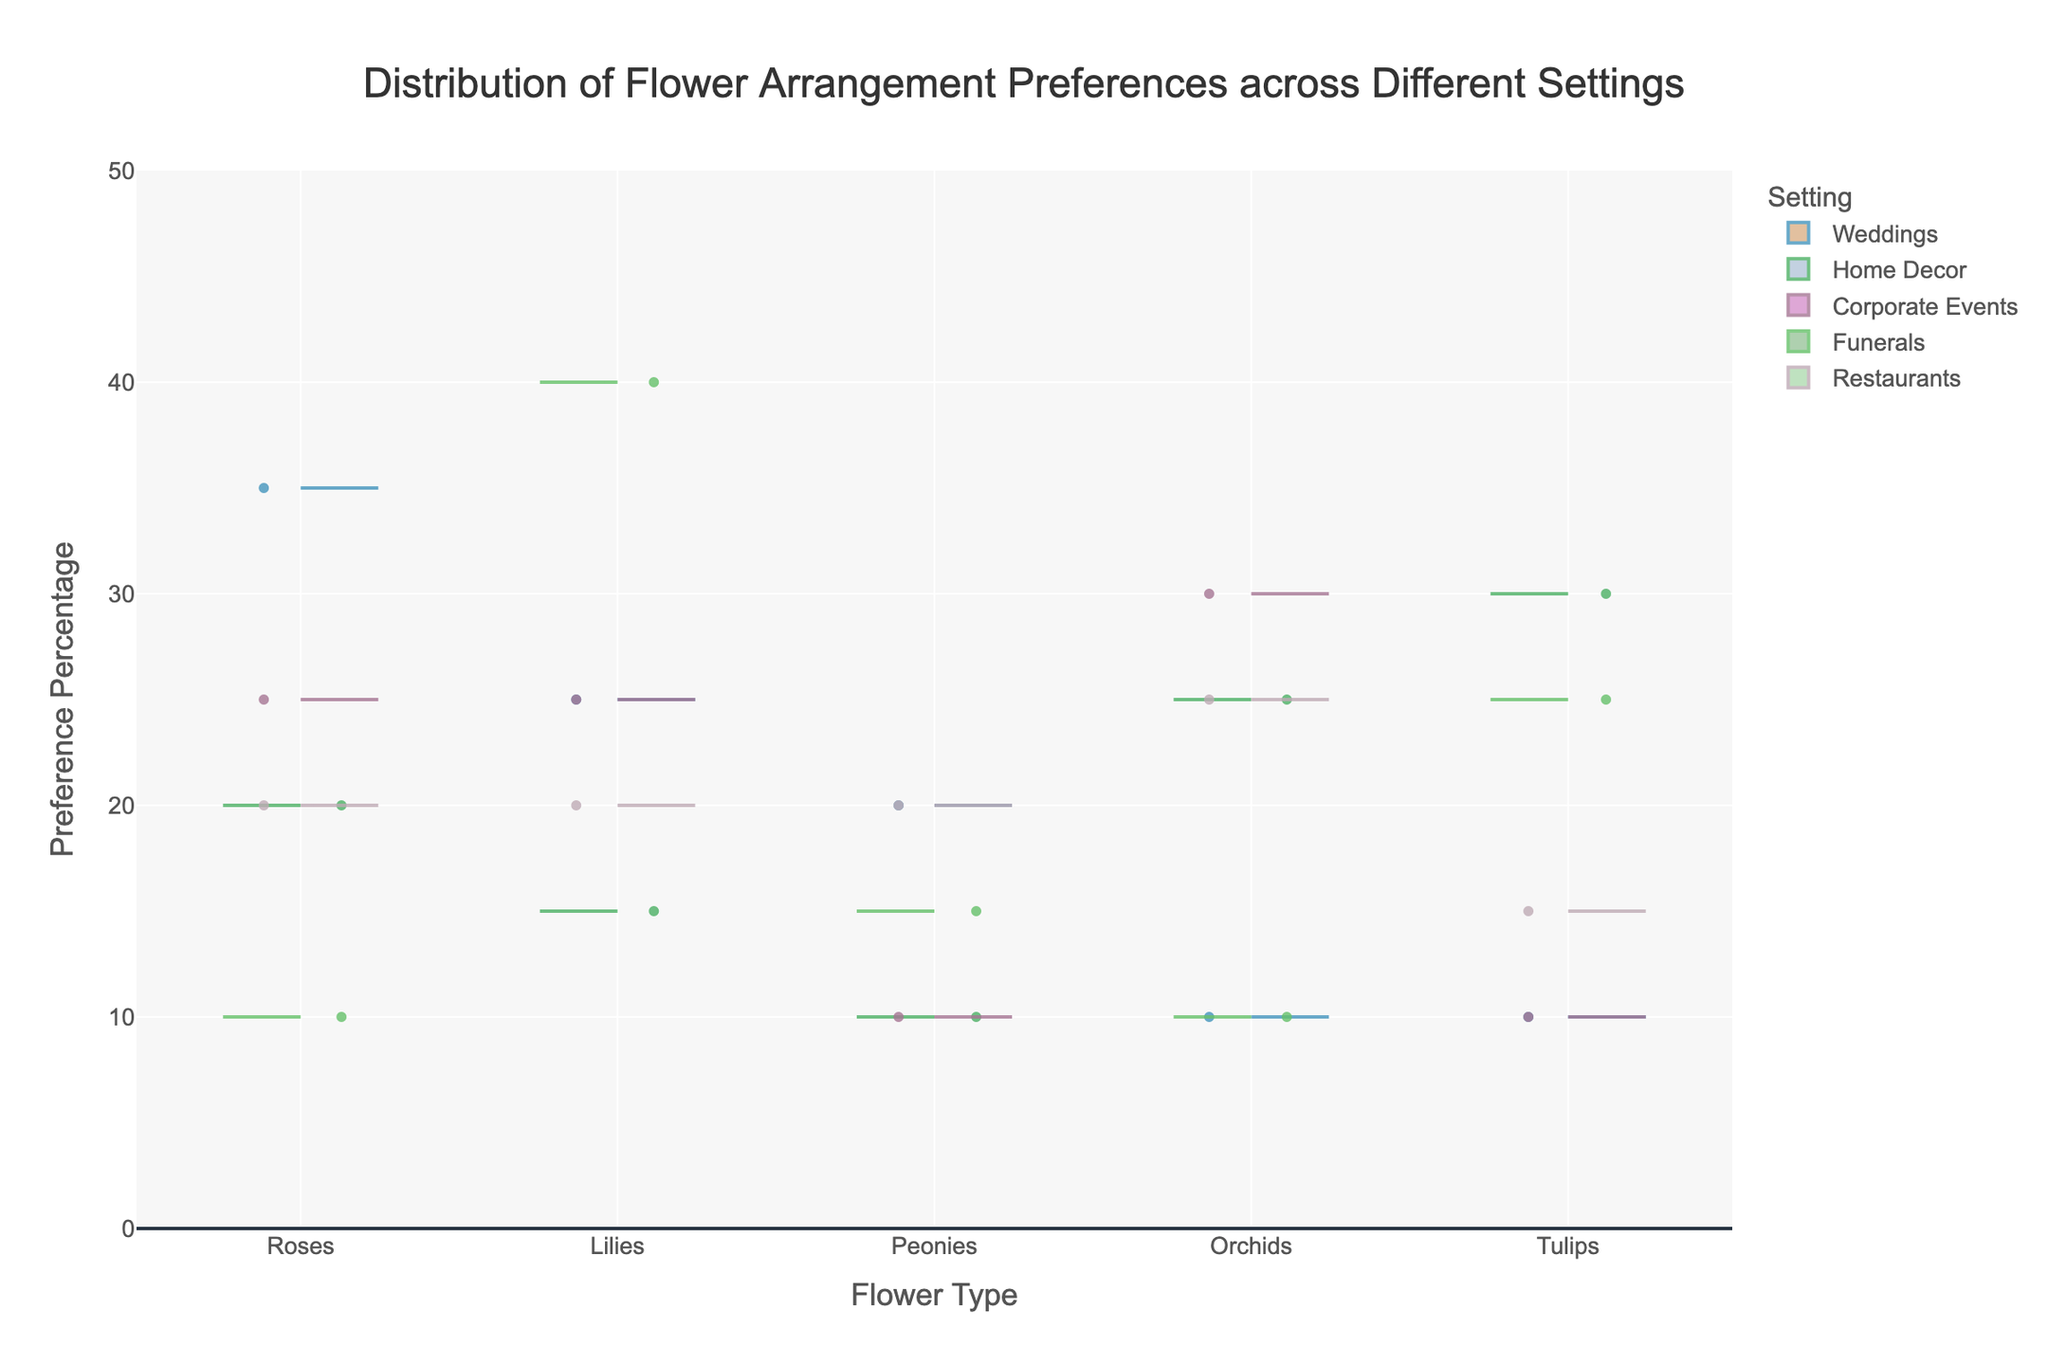How are the flower types labeled on the x-axis? The x-axis represents the different flower types included in the study. You can see "Roses," "Lilies," "Peonies," "Orchids," and "Tulips" labeled on the x-axis.
Answer: Roses, Lilies, Peonies, Orchids, Tulips What is the title of the chart? The title is displayed at the top of the chart and describes the overall theme. In this case, it’s "Distribution of Flower Arrangement Preferences across Different Settings."
Answer: Distribution of Flower Arrangement Preferences across Different Settings Which flower type in the Weddings setting has the highest preference percentage? To determine this, look at the positive side of the violin plot for the Weddings setting. The tallest data point represents "Roses" with a preference percentage of 35%.
Answer: Roses Compare the preference percentages of Orchids in Weddings and Home Decor. Which is higher? For Weddings, Orchids have a 10% preference, and for Home Decor, Orchids have a preference percentage of 25%. You can visually compare the heights of the two data points.
Answer: Home Decor What is the mean preference percentage for Lilies in Corporate Events? The mean value is usually indicated by a white line within the violin plot section for Lilies in the Corporate Events setting. Use the violin plot to see that it is at 25%.
Answer: 25% How do the preference percentages for Peonies compare across all the settings? To compare Peonies, look at their corresponding percentages in each setting. Weddings have 20%, Home Decor has 10%, Corporate Events have 10%, Funerals have 15%, and Restaurants have 20%. By analyzing all these values, you can see the range and differences among them.
Answer: Weddings (20%), Restaurants (20%), Funerals (15%), Home Decor (10%), Corporate Events (10%) Which setting has the least variation in preference percentages? Variation in a violin plot is indicated by the width and spread of the data points. Look for the setting where the plots are the narrowest and closest to the mean line. Funerals show narrow plots for each flower type, indicating the least variation.
Answer: Funerals What is the range of preference percentages for Tulips in Home Decor? The range is determined by the lowest to the highest data points in the violin plot for Tulips in Home Decor. The visualization shows that it ranges from 0% to 30%.
Answer: 0%-30% Compare the preference percentages of the same flower type between two settings: which setting prefers Tulips more, Weddings or Restaurants? Look at the violin plots for Tulips in both the Weddings and Restaurants sections. In Weddings, Tulips have a preference percentage of 10%, while in Restaurants, the percentage is 15%.
Answer: Restaurants What is the highest preference percentage recorded for Lilies across any setting? By examining the tallest Lily violin plots across all settings, Funerals show the highest preference percentage at 40%.
Answer: 40% 